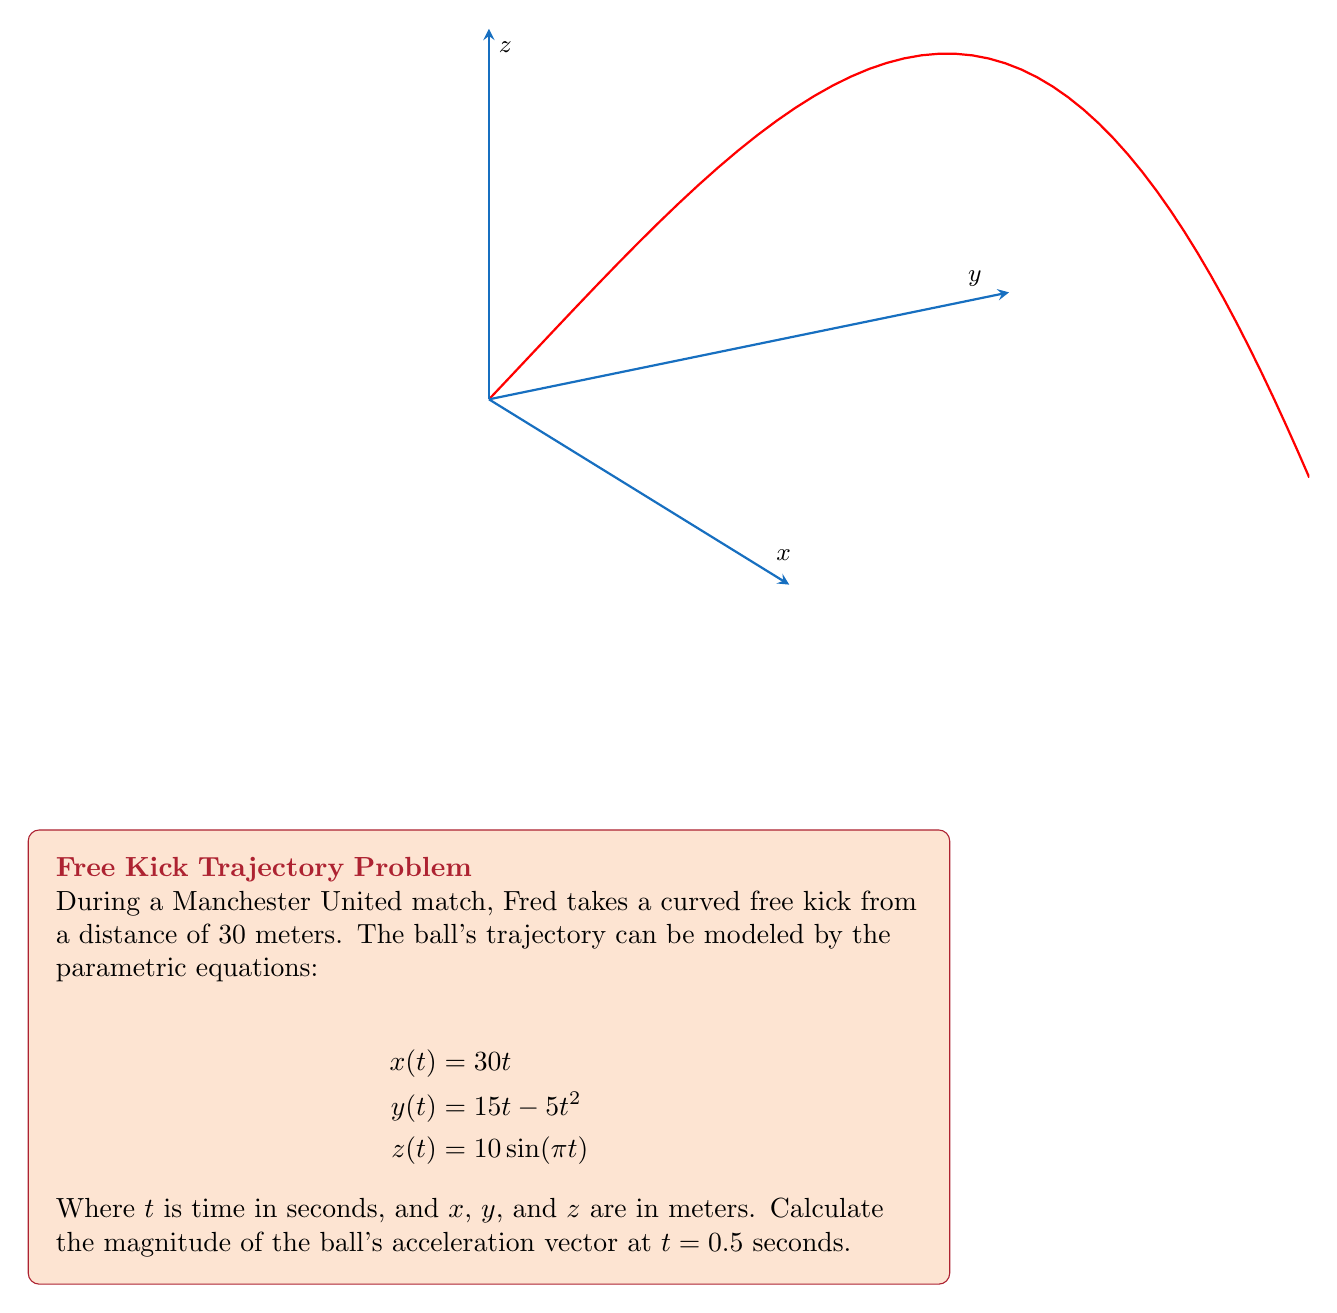Show me your answer to this math problem. Let's approach this step-by-step:

1) First, we need to find the acceleration components in each direction. To do this, we'll take the second derivative of each parametric equation with respect to time.

   For $x(t)$: 
   $\frac{d^2x}{dt^2} = 0$

   For $y(t)$: 
   $\frac{d^2y}{dt^2} = -10$

   For $z(t)$: 
   $\frac{d^2z}{dt^2} = -10\pi^2 \sin(\pi t)$

2) Now, we have the acceleration vector:

   $\vec{a}(t) = (0, -10, -10\pi^2 \sin(\pi t))$

3) At $t = 0.5$ seconds:

   $\vec{a}(0.5) = (0, -10, -10\pi^2 \sin(0.5\pi))$
                 = $(0, -10, -10\pi^2)$

4) To find the magnitude of this acceleration vector, we use the formula:

   $|\vec{a}| = \sqrt{a_x^2 + a_y^2 + a_z^2}$

5) Substituting our values:

   $|\vec{a}| = \sqrt{0^2 + (-10)^2 + (-10\pi^2)^2}$
              = $\sqrt{100 + 100\pi^4}$
              ≈ 98.7 m/s²

Therefore, the magnitude of the ball's acceleration vector at $t = 0.5$ seconds is approximately 98.7 m/s².
Answer: $\sqrt{100 + 100\pi^4}$ m/s² (≈ 98.7 m/s²) 